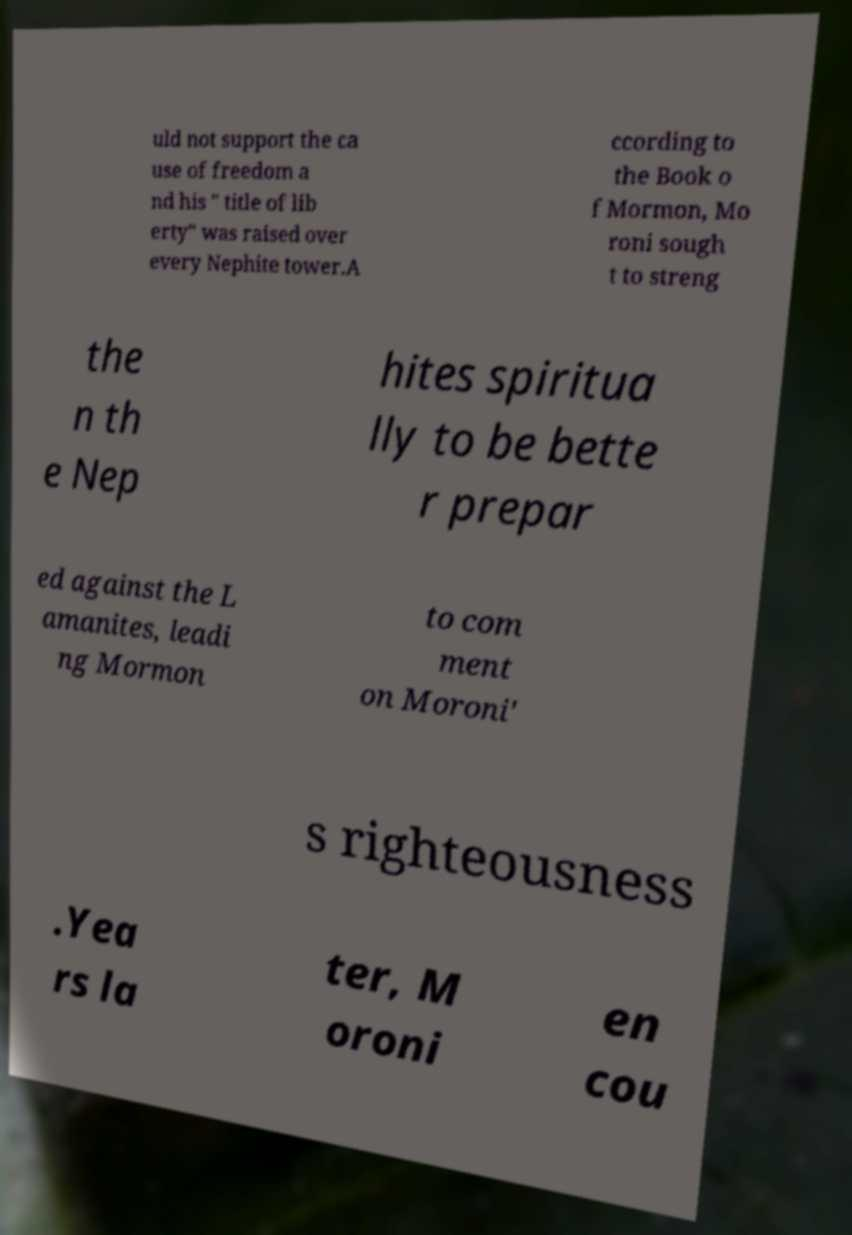I need the written content from this picture converted into text. Can you do that? uld not support the ca use of freedom a nd his " title of lib erty" was raised over every Nephite tower.A ccording to the Book o f Mormon, Mo roni sough t to streng the n th e Nep hites spiritua lly to be bette r prepar ed against the L amanites, leadi ng Mormon to com ment on Moroni' s righteousness .Yea rs la ter, M oroni en cou 